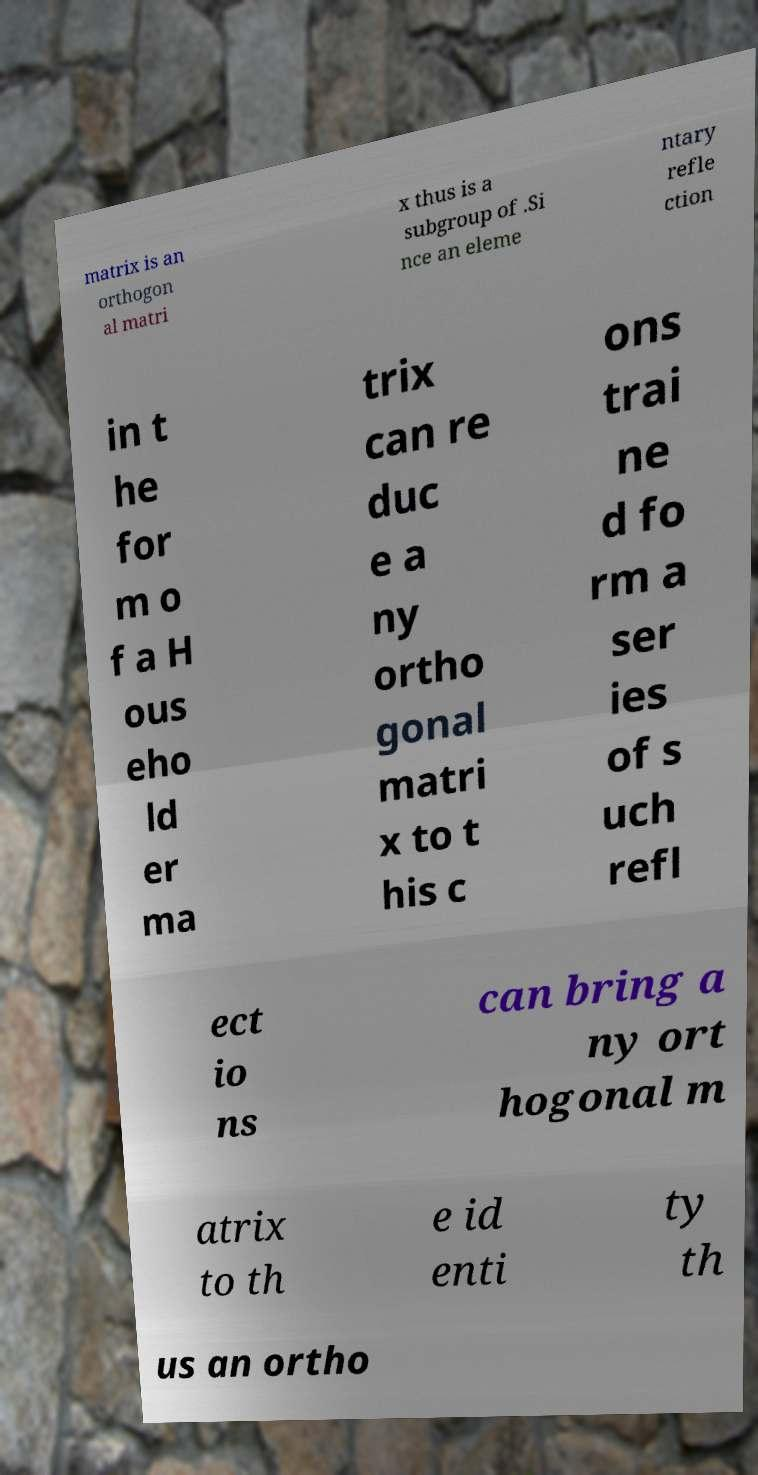For documentation purposes, I need the text within this image transcribed. Could you provide that? matrix is an orthogon al matri x thus is a subgroup of .Si nce an eleme ntary refle ction in t he for m o f a H ous eho ld er ma trix can re duc e a ny ortho gonal matri x to t his c ons trai ne d fo rm a ser ies of s uch refl ect io ns can bring a ny ort hogonal m atrix to th e id enti ty th us an ortho 